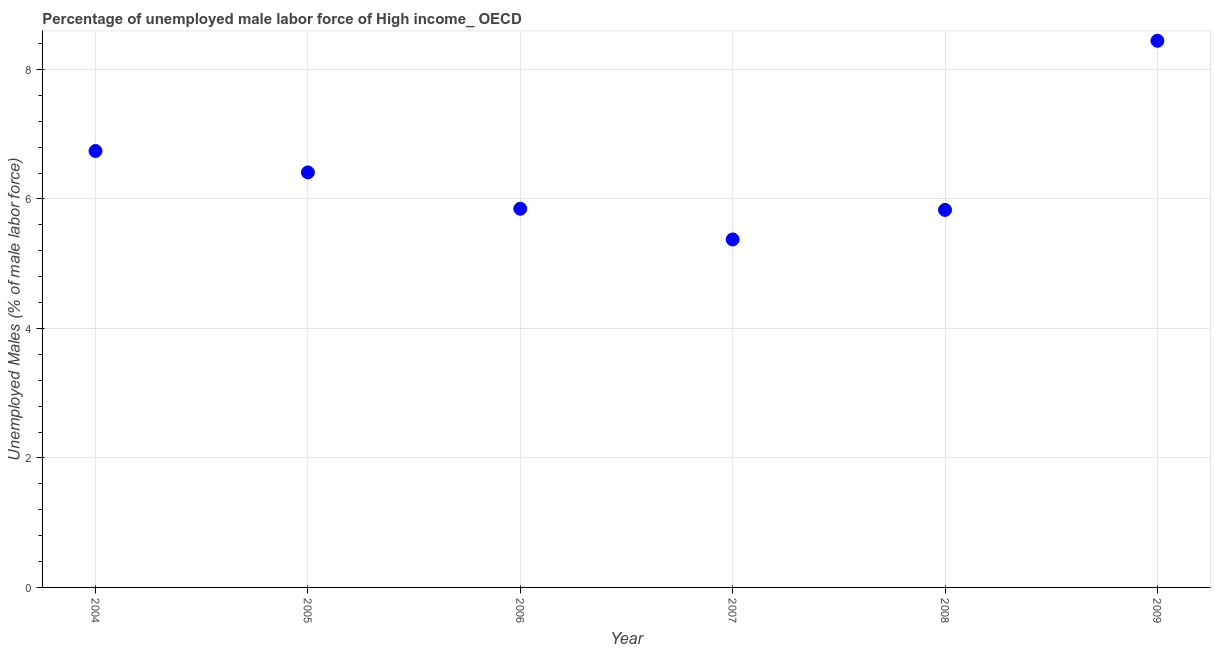What is the total unemployed male labour force in 2008?
Your answer should be compact. 5.83. Across all years, what is the maximum total unemployed male labour force?
Offer a very short reply. 8.44. Across all years, what is the minimum total unemployed male labour force?
Your answer should be very brief. 5.37. In which year was the total unemployed male labour force minimum?
Keep it short and to the point. 2007. What is the sum of the total unemployed male labour force?
Offer a very short reply. 38.64. What is the difference between the total unemployed male labour force in 2006 and 2007?
Keep it short and to the point. 0.47. What is the average total unemployed male labour force per year?
Provide a short and direct response. 6.44. What is the median total unemployed male labour force?
Give a very brief answer. 6.13. In how many years, is the total unemployed male labour force greater than 4.8 %?
Provide a short and direct response. 6. What is the ratio of the total unemployed male labour force in 2004 to that in 2007?
Keep it short and to the point. 1.25. What is the difference between the highest and the second highest total unemployed male labour force?
Ensure brevity in your answer.  1.7. Is the sum of the total unemployed male labour force in 2008 and 2009 greater than the maximum total unemployed male labour force across all years?
Offer a terse response. Yes. What is the difference between the highest and the lowest total unemployed male labour force?
Your answer should be compact. 3.07. In how many years, is the total unemployed male labour force greater than the average total unemployed male labour force taken over all years?
Give a very brief answer. 2. How many dotlines are there?
Your answer should be compact. 1. How many years are there in the graph?
Ensure brevity in your answer.  6. Does the graph contain any zero values?
Your answer should be very brief. No. What is the title of the graph?
Make the answer very short. Percentage of unemployed male labor force of High income_ OECD. What is the label or title of the X-axis?
Your answer should be compact. Year. What is the label or title of the Y-axis?
Your answer should be compact. Unemployed Males (% of male labor force). What is the Unemployed Males (% of male labor force) in 2004?
Your answer should be compact. 6.74. What is the Unemployed Males (% of male labor force) in 2005?
Make the answer very short. 6.41. What is the Unemployed Males (% of male labor force) in 2006?
Provide a short and direct response. 5.85. What is the Unemployed Males (% of male labor force) in 2007?
Make the answer very short. 5.37. What is the Unemployed Males (% of male labor force) in 2008?
Provide a short and direct response. 5.83. What is the Unemployed Males (% of male labor force) in 2009?
Keep it short and to the point. 8.44. What is the difference between the Unemployed Males (% of male labor force) in 2004 and 2005?
Provide a short and direct response. 0.33. What is the difference between the Unemployed Males (% of male labor force) in 2004 and 2006?
Provide a succinct answer. 0.89. What is the difference between the Unemployed Males (% of male labor force) in 2004 and 2007?
Your response must be concise. 1.37. What is the difference between the Unemployed Males (% of male labor force) in 2004 and 2008?
Offer a terse response. 0.91. What is the difference between the Unemployed Males (% of male labor force) in 2004 and 2009?
Give a very brief answer. -1.7. What is the difference between the Unemployed Males (% of male labor force) in 2005 and 2006?
Provide a succinct answer. 0.56. What is the difference between the Unemployed Males (% of male labor force) in 2005 and 2007?
Offer a terse response. 1.04. What is the difference between the Unemployed Males (% of male labor force) in 2005 and 2008?
Keep it short and to the point. 0.58. What is the difference between the Unemployed Males (% of male labor force) in 2005 and 2009?
Provide a short and direct response. -2.03. What is the difference between the Unemployed Males (% of male labor force) in 2006 and 2007?
Your answer should be very brief. 0.47. What is the difference between the Unemployed Males (% of male labor force) in 2006 and 2008?
Ensure brevity in your answer.  0.02. What is the difference between the Unemployed Males (% of male labor force) in 2006 and 2009?
Keep it short and to the point. -2.59. What is the difference between the Unemployed Males (% of male labor force) in 2007 and 2008?
Offer a very short reply. -0.46. What is the difference between the Unemployed Males (% of male labor force) in 2007 and 2009?
Your answer should be very brief. -3.07. What is the difference between the Unemployed Males (% of male labor force) in 2008 and 2009?
Provide a succinct answer. -2.61. What is the ratio of the Unemployed Males (% of male labor force) in 2004 to that in 2005?
Provide a short and direct response. 1.05. What is the ratio of the Unemployed Males (% of male labor force) in 2004 to that in 2006?
Provide a short and direct response. 1.15. What is the ratio of the Unemployed Males (% of male labor force) in 2004 to that in 2007?
Ensure brevity in your answer.  1.25. What is the ratio of the Unemployed Males (% of male labor force) in 2004 to that in 2008?
Your answer should be very brief. 1.16. What is the ratio of the Unemployed Males (% of male labor force) in 2004 to that in 2009?
Keep it short and to the point. 0.8. What is the ratio of the Unemployed Males (% of male labor force) in 2005 to that in 2006?
Ensure brevity in your answer.  1.1. What is the ratio of the Unemployed Males (% of male labor force) in 2005 to that in 2007?
Make the answer very short. 1.19. What is the ratio of the Unemployed Males (% of male labor force) in 2005 to that in 2008?
Offer a terse response. 1.1. What is the ratio of the Unemployed Males (% of male labor force) in 2005 to that in 2009?
Keep it short and to the point. 0.76. What is the ratio of the Unemployed Males (% of male labor force) in 2006 to that in 2007?
Keep it short and to the point. 1.09. What is the ratio of the Unemployed Males (% of male labor force) in 2006 to that in 2009?
Ensure brevity in your answer.  0.69. What is the ratio of the Unemployed Males (% of male labor force) in 2007 to that in 2008?
Keep it short and to the point. 0.92. What is the ratio of the Unemployed Males (% of male labor force) in 2007 to that in 2009?
Your response must be concise. 0.64. What is the ratio of the Unemployed Males (% of male labor force) in 2008 to that in 2009?
Provide a short and direct response. 0.69. 